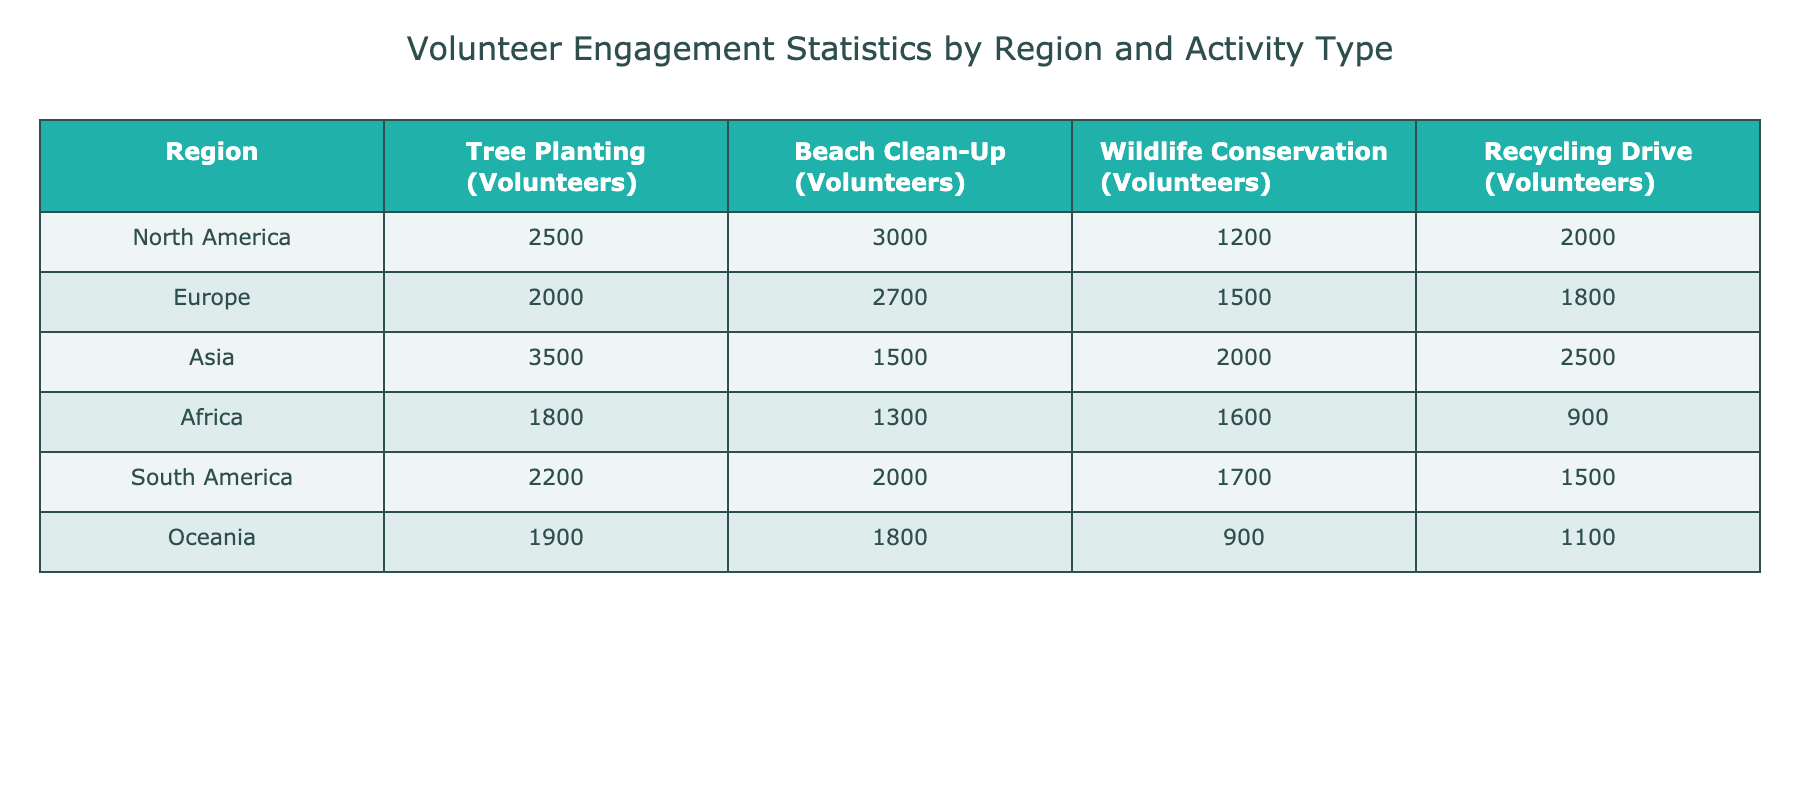What region has the highest number of volunteers for tree planting? The table shows the values for the Tree Planting column, where Asia has the highest number of volunteers at 3500.
Answer: Asia Which activity engaged the least number of volunteers in Oceania? In the Recycling Drive column for Oceania, the number of volunteers is 1100, which is less than that of other activities listed.
Answer: Recycling Drive What is the total number of volunteers participating in Wildlife Conservation across all regions? By adding the values in the Wildlife Conservation column: 1200 (North America) + 1500 (Europe) + 2000 (Asia) + 1600 (Africa) + 1700 (South America) + 900 (Oceania) = 10,900.
Answer: 10900 Is it true that Europe has more volunteers for Beach Clean-Up than for Wildlife Conservation? In the Beach Clean-Up column, Europe has 2700 volunteers, compared to 1500 for Wildlife Conservation in the same region, making this statement true.
Answer: Yes Which activity has the highest engagement in South America? Checking the South America row, the highest number of volunteers is for Beach Clean-Up, with 2000 volunteers, compared to the others.
Answer: Beach Clean-Up What is the average number of volunteers for Recycling Drives across all regions? The total number of volunteers for Recycling Drives is 2000 (North America) + 1800 (Europe) + 2500 (Asia) + 900 (Africa) + 1500 (South America) + 1100 (Oceania) = 10,800. Since there are 6 regions, the average is 10,800 / 6 = 1800.
Answer: 1800 Does Africa have more volunteers for any activity compared to Oceania? By comparing the volunteers in each activity for both regions, Africa has more for Tree Planting (1800 vs 1900) and Wildlife Conservation (1600 vs 900) but fewer for Beach Clean-Up and Recycling Drive, meaning this is not fully true.
Answer: No What is the difference between the number of volunteers in Recycling Drives in North America and Africa? In the Recycling Drive column, North America has 2000 volunteers while Africa has 900 volunteers. The difference is 2000 - 900 = 1100.
Answer: 1100 